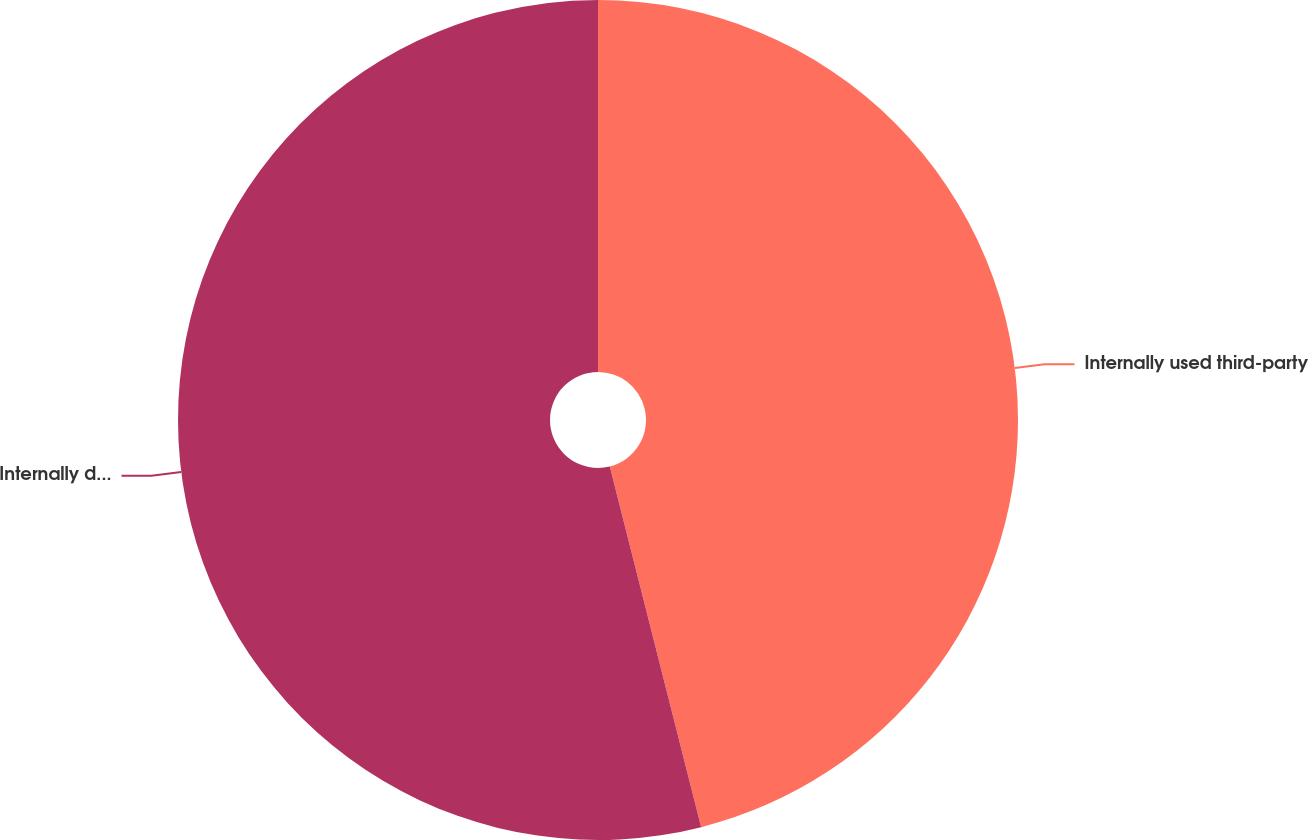Convert chart. <chart><loc_0><loc_0><loc_500><loc_500><pie_chart><fcel>Internally used third-party<fcel>Internally developed software<nl><fcel>46.05%<fcel>53.95%<nl></chart> 